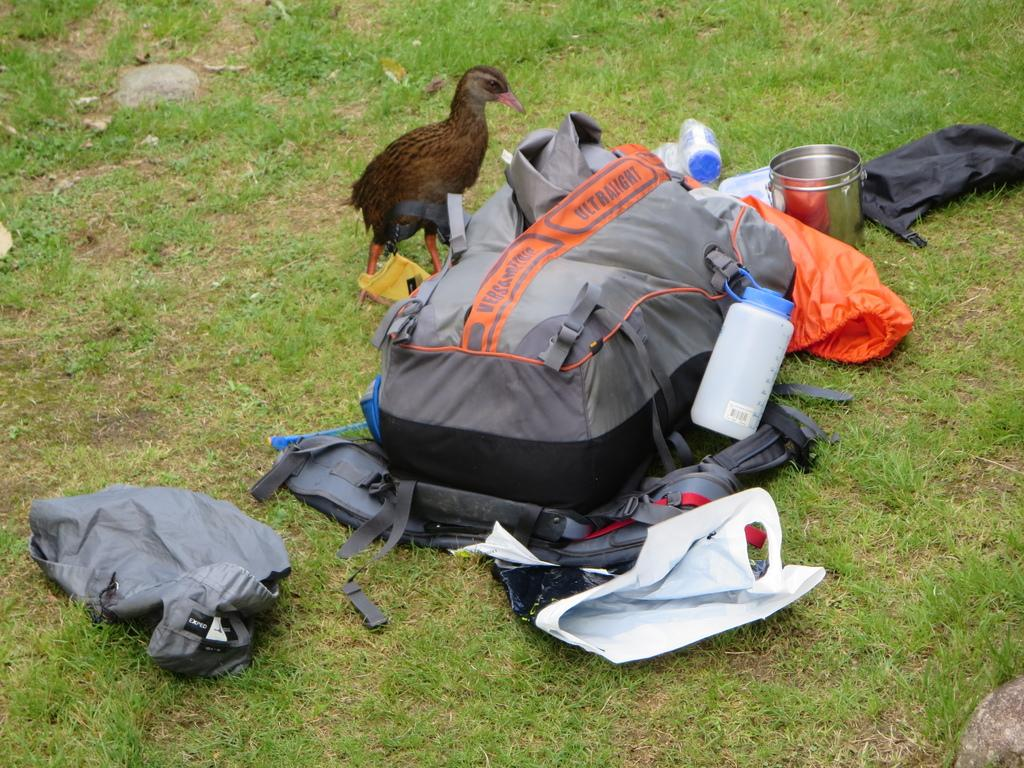What type of animal can be seen in the image? There is a bird in the image. What object is present that might be used for carrying items? There is a bag in the image. What object is present that might be used for holding a liquid? There is a bottle in the image. What object is present that might be used for eating or drinking? There is a utensil in the image. What type of cloth is being used for amusement in the image? There is no cloth or amusement present in the image. 